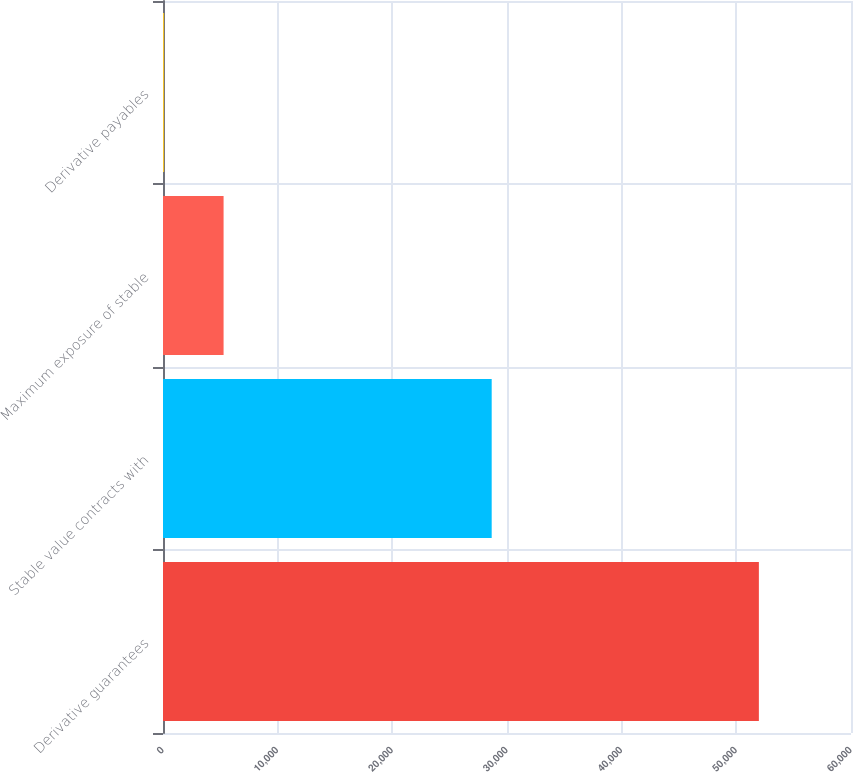Convert chart to OTSL. <chart><loc_0><loc_0><loc_500><loc_500><bar_chart><fcel>Derivative guarantees<fcel>Stable value contracts with<fcel>Maximum exposure of stable<fcel>Derivative payables<nl><fcel>51966<fcel>28665<fcel>5283<fcel>96<nl></chart> 